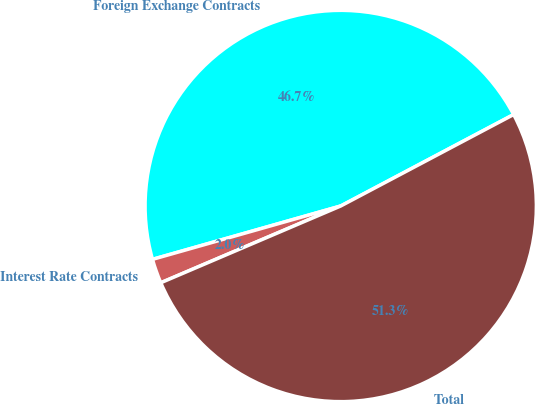<chart> <loc_0><loc_0><loc_500><loc_500><pie_chart><fcel>Foreign Exchange Contracts<fcel>Interest Rate Contracts<fcel>Total<nl><fcel>46.65%<fcel>2.02%<fcel>51.32%<nl></chart> 